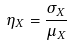<formula> <loc_0><loc_0><loc_500><loc_500>\eta _ { X } = \frac { \sigma _ { X } } { \mu _ { X } }</formula> 